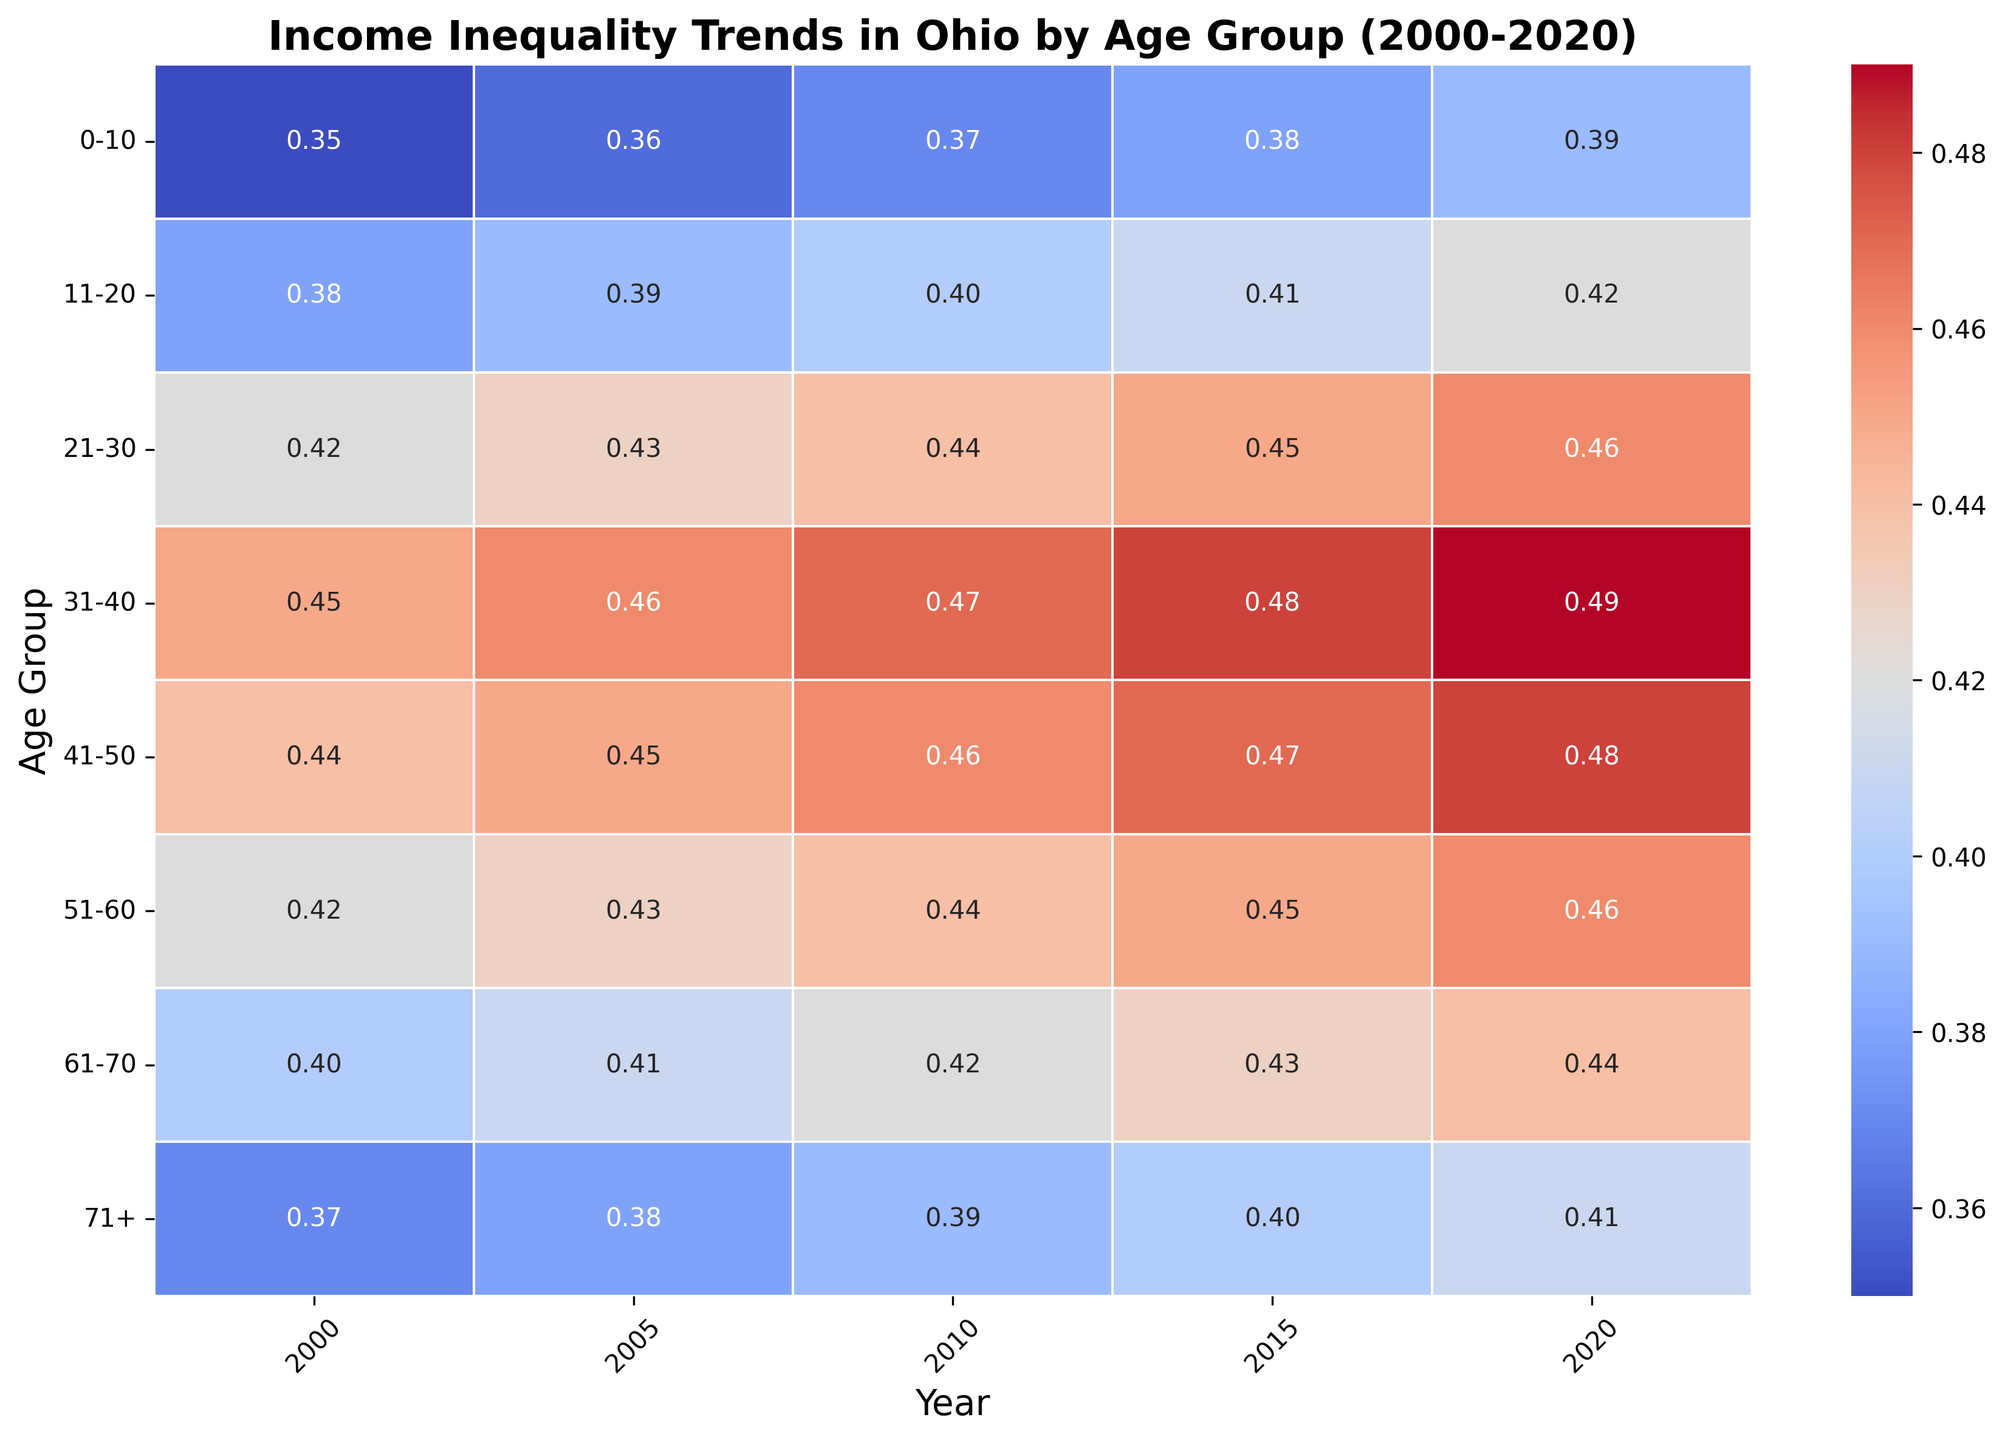What age group saw the highest income inequality in 2020? To answer this, look at the "2020" column and find the cell with the highest value. The highest value in this column is 0.49 in the "31-40" age group.
Answer: 31-40 Which age group experienced the most significant increase in income inequality from 2000 to 2020? To answer this, find the difference for each age group between its 2020 value and its 2000 value. The differences are:  
0-10: 0.39 - 0.35 = 0.04  
11-20: 0.42 - 0.38 = 0.04  
21-30: 0.46 - 0.42 = 0.04  
31-40: 0.49 - 0.45 = 0.04  
41-50: 0.48 - 0.44 = 0.04  
51-60: 0.46 - 0.42 = 0.04  
61-70: 0.44 - 0.40 = 0.04  
71+: 0.41 - 0.37 = 0.04  
Each age group has the same increase of 0.04 from 2000 to 2020.
Answer: 0-10, 11-20, 21-30, 31-40, 41-50, 51-60, 61-70, 71+ How did income inequality for the age group 41-50 change from 2005 to 2015? To answer this, look at the values for the 41-50 age group in 2005 and 2015. In 2005, the value is 0.45; in 2015, the value is 0.47. The change is 0.47 - 0.45 = 0.02.
Answer: Increased by 0.02 Comparing income inequality in 2015, which age group had a higher value: 21-30 or 51-60? To answer this, look at the values for 21-30 and 51-60 for the year 2015. For 21-30, the value is 0.45; for 51-60, the value is 0.45. Both groups have the same value.
Answer: Equal What was the average income inequality of the 0-10 age group across all years from 2000 to 2020? To answer this, sum up the values for the age group 0-10 from 2000 to 2020 and divide by the number of years.  
0.35 (2000) + 0.36 (2005) + 0.37 (2010) + 0.38 (2015) + 0.39 (2020) = 1.85  
1.85 / 5 = 0.37
Answer: 0.37 Which year's data shows the most similar income inequality values across all age groups? To answer this, identify the year with values that have the smallest range (difference between the highest and lowest values).  
For 2000: Range = 0.45 - 0.35 = 0.10  
For 2005: Range = 0.46 - 0.36 = 0.10  
For 2010: Range = 0.47 - 0.37 = 0.10  
For 2015: Range = 0.48 - 0.38 = 0.10  
For 2020: Range = 0.49 - 0.39 = 0.10  
Every year has the same range.
Answer: Every year has the same range What is the color trend for income inequality values greater than 0.45? To answer this, observe the colors representing values greater than 0.45. These colors are generally in the red-to-pink spectrum hinting high values are in this color range.
Answer: Red-to-pink spectrum 